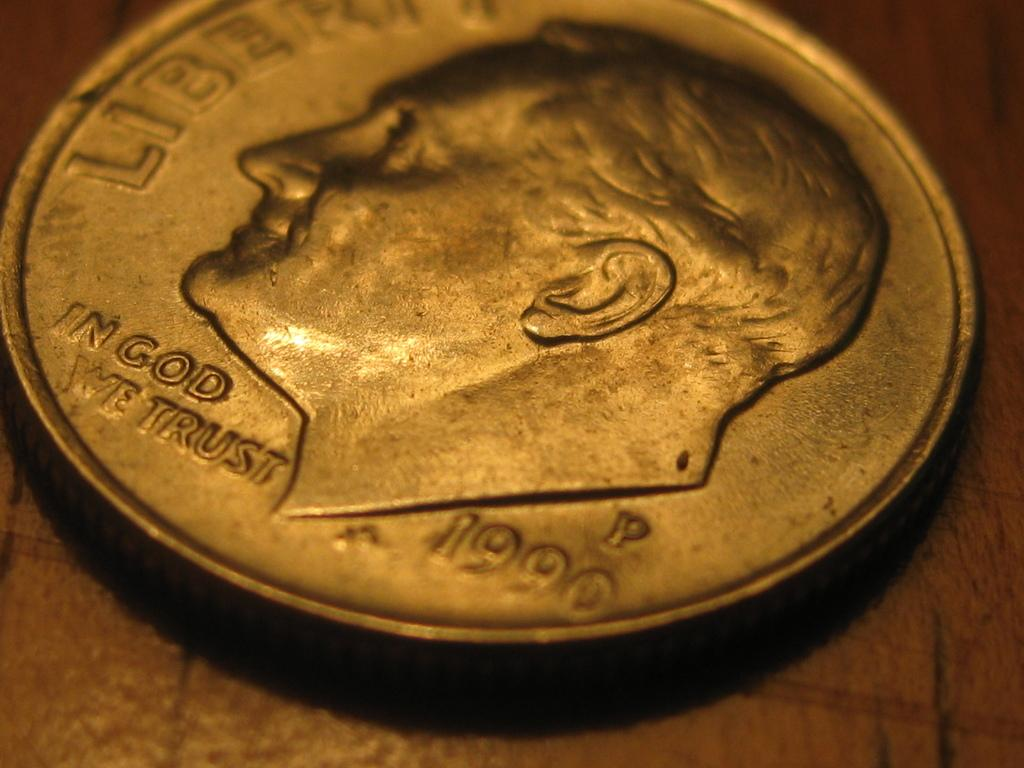<image>
Share a concise interpretation of the image provided. Silver coin showing a face and the year 1990. 